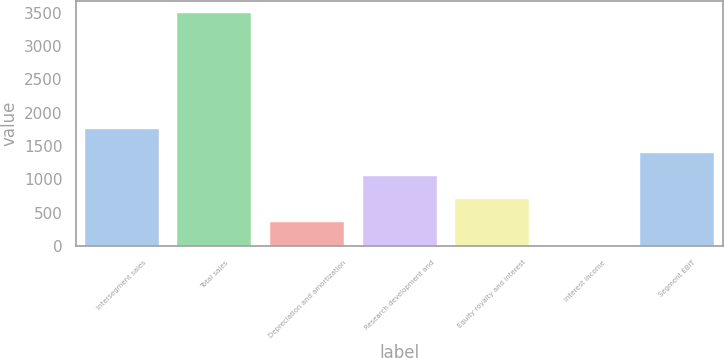Convert chart to OTSL. <chart><loc_0><loc_0><loc_500><loc_500><bar_chart><fcel>Intersegment sales<fcel>Total sales<fcel>Depreciation and amortization<fcel>Research development and<fcel>Equity royalty and interest<fcel>Interest income<fcel>Segment EBIT<nl><fcel>1753<fcel>3498<fcel>357<fcel>1055<fcel>706<fcel>8<fcel>1404<nl></chart> 